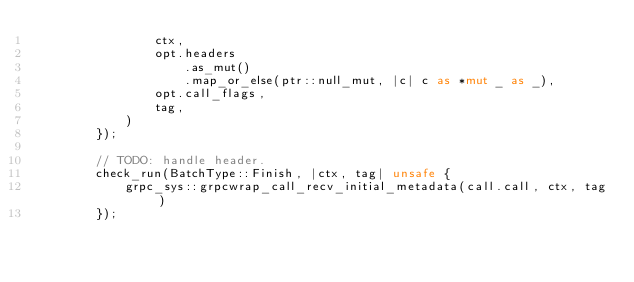Convert code to text. <code><loc_0><loc_0><loc_500><loc_500><_Rust_>                ctx,
                opt.headers
                    .as_mut()
                    .map_or_else(ptr::null_mut, |c| c as *mut _ as _),
                opt.call_flags,
                tag,
            )
        });

        // TODO: handle header.
        check_run(BatchType::Finish, |ctx, tag| unsafe {
            grpc_sys::grpcwrap_call_recv_initial_metadata(call.call, ctx, tag)
        });
</code> 